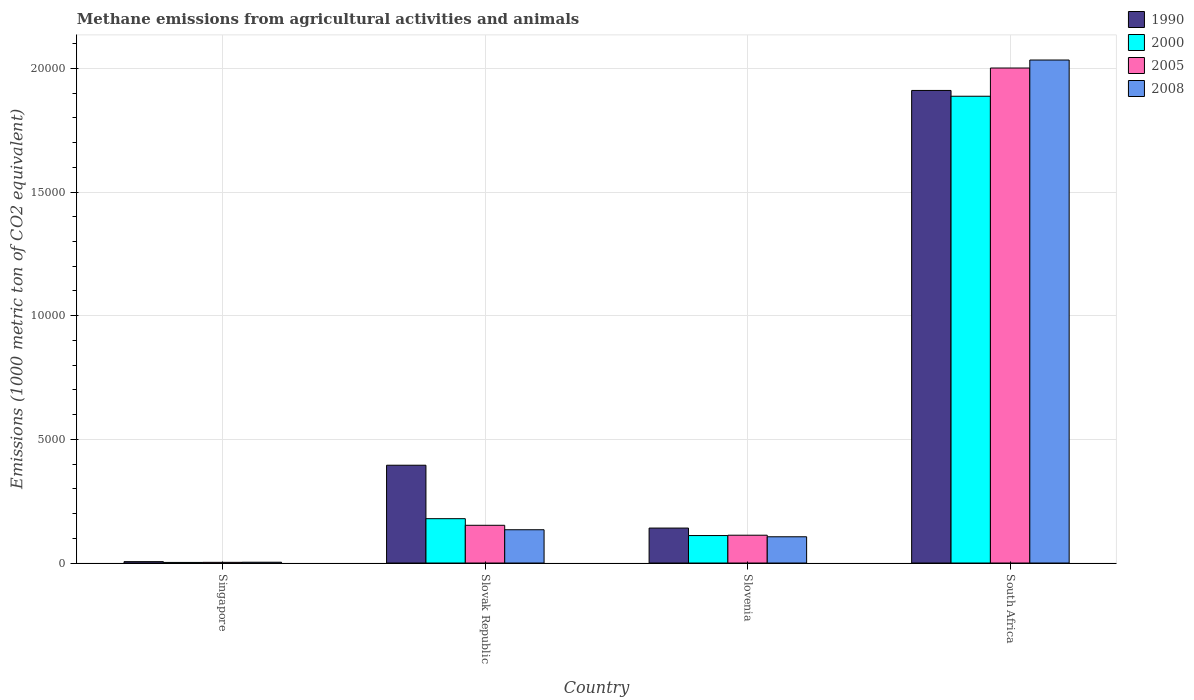Are the number of bars on each tick of the X-axis equal?
Your response must be concise. Yes. How many bars are there on the 4th tick from the left?
Give a very brief answer. 4. What is the label of the 1st group of bars from the left?
Ensure brevity in your answer.  Singapore. In how many cases, is the number of bars for a given country not equal to the number of legend labels?
Provide a succinct answer. 0. What is the amount of methane emitted in 2005 in Singapore?
Your answer should be very brief. 28.4. Across all countries, what is the maximum amount of methane emitted in 2005?
Make the answer very short. 2.00e+04. Across all countries, what is the minimum amount of methane emitted in 2005?
Make the answer very short. 28.4. In which country was the amount of methane emitted in 2000 maximum?
Your answer should be compact. South Africa. In which country was the amount of methane emitted in 2005 minimum?
Offer a terse response. Singapore. What is the total amount of methane emitted in 2000 in the graph?
Your response must be concise. 2.18e+04. What is the difference between the amount of methane emitted in 1990 in Singapore and that in Slovenia?
Offer a very short reply. -1357.9. What is the difference between the amount of methane emitted in 2000 in Slovenia and the amount of methane emitted in 1990 in Slovak Republic?
Provide a short and direct response. -2843.5. What is the average amount of methane emitted in 2008 per country?
Make the answer very short. 5694.55. In how many countries, is the amount of methane emitted in 2000 greater than 17000 1000 metric ton?
Provide a short and direct response. 1. What is the ratio of the amount of methane emitted in 1990 in Singapore to that in Slovak Republic?
Offer a terse response. 0.01. Is the difference between the amount of methane emitted in 2000 in Singapore and South Africa greater than the difference between the amount of methane emitted in 2005 in Singapore and South Africa?
Keep it short and to the point. Yes. What is the difference between the highest and the second highest amount of methane emitted in 2005?
Give a very brief answer. -401.3. What is the difference between the highest and the lowest amount of methane emitted in 1990?
Ensure brevity in your answer.  1.91e+04. What does the 4th bar from the right in South Africa represents?
Offer a terse response. 1990. Are all the bars in the graph horizontal?
Your response must be concise. No. Are the values on the major ticks of Y-axis written in scientific E-notation?
Provide a short and direct response. No. Does the graph contain any zero values?
Provide a succinct answer. No. Does the graph contain grids?
Your response must be concise. Yes. How many legend labels are there?
Offer a very short reply. 4. How are the legend labels stacked?
Offer a very short reply. Vertical. What is the title of the graph?
Provide a short and direct response. Methane emissions from agricultural activities and animals. Does "1962" appear as one of the legend labels in the graph?
Provide a short and direct response. No. What is the label or title of the Y-axis?
Keep it short and to the point. Emissions (1000 metric ton of CO2 equivalent). What is the Emissions (1000 metric ton of CO2 equivalent) in 1990 in Singapore?
Offer a very short reply. 55.6. What is the Emissions (1000 metric ton of CO2 equivalent) in 2000 in Singapore?
Ensure brevity in your answer.  24.4. What is the Emissions (1000 metric ton of CO2 equivalent) of 2005 in Singapore?
Your response must be concise. 28.4. What is the Emissions (1000 metric ton of CO2 equivalent) in 2008 in Singapore?
Provide a succinct answer. 32.8. What is the Emissions (1000 metric ton of CO2 equivalent) of 1990 in Slovak Republic?
Give a very brief answer. 3954.5. What is the Emissions (1000 metric ton of CO2 equivalent) of 2000 in Slovak Republic?
Provide a short and direct response. 1793.2. What is the Emissions (1000 metric ton of CO2 equivalent) in 2005 in Slovak Republic?
Your answer should be compact. 1525.9. What is the Emissions (1000 metric ton of CO2 equivalent) of 2008 in Slovak Republic?
Ensure brevity in your answer.  1345.7. What is the Emissions (1000 metric ton of CO2 equivalent) of 1990 in Slovenia?
Offer a very short reply. 1413.5. What is the Emissions (1000 metric ton of CO2 equivalent) in 2000 in Slovenia?
Give a very brief answer. 1111. What is the Emissions (1000 metric ton of CO2 equivalent) of 2005 in Slovenia?
Ensure brevity in your answer.  1124.6. What is the Emissions (1000 metric ton of CO2 equivalent) in 2008 in Slovenia?
Keep it short and to the point. 1061.8. What is the Emissions (1000 metric ton of CO2 equivalent) of 1990 in South Africa?
Your answer should be very brief. 1.91e+04. What is the Emissions (1000 metric ton of CO2 equivalent) in 2000 in South Africa?
Offer a terse response. 1.89e+04. What is the Emissions (1000 metric ton of CO2 equivalent) of 2005 in South Africa?
Make the answer very short. 2.00e+04. What is the Emissions (1000 metric ton of CO2 equivalent) in 2008 in South Africa?
Ensure brevity in your answer.  2.03e+04. Across all countries, what is the maximum Emissions (1000 metric ton of CO2 equivalent) in 1990?
Make the answer very short. 1.91e+04. Across all countries, what is the maximum Emissions (1000 metric ton of CO2 equivalent) in 2000?
Your answer should be very brief. 1.89e+04. Across all countries, what is the maximum Emissions (1000 metric ton of CO2 equivalent) of 2005?
Give a very brief answer. 2.00e+04. Across all countries, what is the maximum Emissions (1000 metric ton of CO2 equivalent) in 2008?
Offer a very short reply. 2.03e+04. Across all countries, what is the minimum Emissions (1000 metric ton of CO2 equivalent) of 1990?
Give a very brief answer. 55.6. Across all countries, what is the minimum Emissions (1000 metric ton of CO2 equivalent) in 2000?
Ensure brevity in your answer.  24.4. Across all countries, what is the minimum Emissions (1000 metric ton of CO2 equivalent) in 2005?
Ensure brevity in your answer.  28.4. Across all countries, what is the minimum Emissions (1000 metric ton of CO2 equivalent) in 2008?
Your response must be concise. 32.8. What is the total Emissions (1000 metric ton of CO2 equivalent) of 1990 in the graph?
Make the answer very short. 2.45e+04. What is the total Emissions (1000 metric ton of CO2 equivalent) of 2000 in the graph?
Keep it short and to the point. 2.18e+04. What is the total Emissions (1000 metric ton of CO2 equivalent) of 2005 in the graph?
Give a very brief answer. 2.27e+04. What is the total Emissions (1000 metric ton of CO2 equivalent) of 2008 in the graph?
Ensure brevity in your answer.  2.28e+04. What is the difference between the Emissions (1000 metric ton of CO2 equivalent) in 1990 in Singapore and that in Slovak Republic?
Provide a succinct answer. -3898.9. What is the difference between the Emissions (1000 metric ton of CO2 equivalent) in 2000 in Singapore and that in Slovak Republic?
Ensure brevity in your answer.  -1768.8. What is the difference between the Emissions (1000 metric ton of CO2 equivalent) of 2005 in Singapore and that in Slovak Republic?
Provide a short and direct response. -1497.5. What is the difference between the Emissions (1000 metric ton of CO2 equivalent) in 2008 in Singapore and that in Slovak Republic?
Your answer should be very brief. -1312.9. What is the difference between the Emissions (1000 metric ton of CO2 equivalent) of 1990 in Singapore and that in Slovenia?
Offer a terse response. -1357.9. What is the difference between the Emissions (1000 metric ton of CO2 equivalent) of 2000 in Singapore and that in Slovenia?
Keep it short and to the point. -1086.6. What is the difference between the Emissions (1000 metric ton of CO2 equivalent) of 2005 in Singapore and that in Slovenia?
Give a very brief answer. -1096.2. What is the difference between the Emissions (1000 metric ton of CO2 equivalent) of 2008 in Singapore and that in Slovenia?
Give a very brief answer. -1029. What is the difference between the Emissions (1000 metric ton of CO2 equivalent) of 1990 in Singapore and that in South Africa?
Your response must be concise. -1.91e+04. What is the difference between the Emissions (1000 metric ton of CO2 equivalent) of 2000 in Singapore and that in South Africa?
Provide a succinct answer. -1.88e+04. What is the difference between the Emissions (1000 metric ton of CO2 equivalent) in 2005 in Singapore and that in South Africa?
Offer a very short reply. -2.00e+04. What is the difference between the Emissions (1000 metric ton of CO2 equivalent) in 2008 in Singapore and that in South Africa?
Keep it short and to the point. -2.03e+04. What is the difference between the Emissions (1000 metric ton of CO2 equivalent) in 1990 in Slovak Republic and that in Slovenia?
Keep it short and to the point. 2541. What is the difference between the Emissions (1000 metric ton of CO2 equivalent) of 2000 in Slovak Republic and that in Slovenia?
Offer a very short reply. 682.2. What is the difference between the Emissions (1000 metric ton of CO2 equivalent) in 2005 in Slovak Republic and that in Slovenia?
Ensure brevity in your answer.  401.3. What is the difference between the Emissions (1000 metric ton of CO2 equivalent) of 2008 in Slovak Republic and that in Slovenia?
Your response must be concise. 283.9. What is the difference between the Emissions (1000 metric ton of CO2 equivalent) of 1990 in Slovak Republic and that in South Africa?
Give a very brief answer. -1.52e+04. What is the difference between the Emissions (1000 metric ton of CO2 equivalent) in 2000 in Slovak Republic and that in South Africa?
Your answer should be compact. -1.71e+04. What is the difference between the Emissions (1000 metric ton of CO2 equivalent) in 2005 in Slovak Republic and that in South Africa?
Your answer should be very brief. -1.85e+04. What is the difference between the Emissions (1000 metric ton of CO2 equivalent) in 2008 in Slovak Republic and that in South Africa?
Give a very brief answer. -1.90e+04. What is the difference between the Emissions (1000 metric ton of CO2 equivalent) of 1990 in Slovenia and that in South Africa?
Your answer should be compact. -1.77e+04. What is the difference between the Emissions (1000 metric ton of CO2 equivalent) in 2000 in Slovenia and that in South Africa?
Provide a short and direct response. -1.78e+04. What is the difference between the Emissions (1000 metric ton of CO2 equivalent) in 2005 in Slovenia and that in South Africa?
Ensure brevity in your answer.  -1.89e+04. What is the difference between the Emissions (1000 metric ton of CO2 equivalent) of 2008 in Slovenia and that in South Africa?
Your answer should be very brief. -1.93e+04. What is the difference between the Emissions (1000 metric ton of CO2 equivalent) in 1990 in Singapore and the Emissions (1000 metric ton of CO2 equivalent) in 2000 in Slovak Republic?
Your response must be concise. -1737.6. What is the difference between the Emissions (1000 metric ton of CO2 equivalent) in 1990 in Singapore and the Emissions (1000 metric ton of CO2 equivalent) in 2005 in Slovak Republic?
Provide a succinct answer. -1470.3. What is the difference between the Emissions (1000 metric ton of CO2 equivalent) in 1990 in Singapore and the Emissions (1000 metric ton of CO2 equivalent) in 2008 in Slovak Republic?
Provide a short and direct response. -1290.1. What is the difference between the Emissions (1000 metric ton of CO2 equivalent) in 2000 in Singapore and the Emissions (1000 metric ton of CO2 equivalent) in 2005 in Slovak Republic?
Your answer should be compact. -1501.5. What is the difference between the Emissions (1000 metric ton of CO2 equivalent) of 2000 in Singapore and the Emissions (1000 metric ton of CO2 equivalent) of 2008 in Slovak Republic?
Offer a terse response. -1321.3. What is the difference between the Emissions (1000 metric ton of CO2 equivalent) in 2005 in Singapore and the Emissions (1000 metric ton of CO2 equivalent) in 2008 in Slovak Republic?
Make the answer very short. -1317.3. What is the difference between the Emissions (1000 metric ton of CO2 equivalent) of 1990 in Singapore and the Emissions (1000 metric ton of CO2 equivalent) of 2000 in Slovenia?
Offer a very short reply. -1055.4. What is the difference between the Emissions (1000 metric ton of CO2 equivalent) of 1990 in Singapore and the Emissions (1000 metric ton of CO2 equivalent) of 2005 in Slovenia?
Your response must be concise. -1069. What is the difference between the Emissions (1000 metric ton of CO2 equivalent) in 1990 in Singapore and the Emissions (1000 metric ton of CO2 equivalent) in 2008 in Slovenia?
Give a very brief answer. -1006.2. What is the difference between the Emissions (1000 metric ton of CO2 equivalent) of 2000 in Singapore and the Emissions (1000 metric ton of CO2 equivalent) of 2005 in Slovenia?
Offer a very short reply. -1100.2. What is the difference between the Emissions (1000 metric ton of CO2 equivalent) of 2000 in Singapore and the Emissions (1000 metric ton of CO2 equivalent) of 2008 in Slovenia?
Provide a short and direct response. -1037.4. What is the difference between the Emissions (1000 metric ton of CO2 equivalent) of 2005 in Singapore and the Emissions (1000 metric ton of CO2 equivalent) of 2008 in Slovenia?
Offer a terse response. -1033.4. What is the difference between the Emissions (1000 metric ton of CO2 equivalent) of 1990 in Singapore and the Emissions (1000 metric ton of CO2 equivalent) of 2000 in South Africa?
Give a very brief answer. -1.88e+04. What is the difference between the Emissions (1000 metric ton of CO2 equivalent) in 1990 in Singapore and the Emissions (1000 metric ton of CO2 equivalent) in 2005 in South Africa?
Provide a succinct answer. -2.00e+04. What is the difference between the Emissions (1000 metric ton of CO2 equivalent) of 1990 in Singapore and the Emissions (1000 metric ton of CO2 equivalent) of 2008 in South Africa?
Offer a terse response. -2.03e+04. What is the difference between the Emissions (1000 metric ton of CO2 equivalent) of 2000 in Singapore and the Emissions (1000 metric ton of CO2 equivalent) of 2005 in South Africa?
Offer a very short reply. -2.00e+04. What is the difference between the Emissions (1000 metric ton of CO2 equivalent) in 2000 in Singapore and the Emissions (1000 metric ton of CO2 equivalent) in 2008 in South Africa?
Your answer should be compact. -2.03e+04. What is the difference between the Emissions (1000 metric ton of CO2 equivalent) of 2005 in Singapore and the Emissions (1000 metric ton of CO2 equivalent) of 2008 in South Africa?
Offer a very short reply. -2.03e+04. What is the difference between the Emissions (1000 metric ton of CO2 equivalent) of 1990 in Slovak Republic and the Emissions (1000 metric ton of CO2 equivalent) of 2000 in Slovenia?
Your answer should be compact. 2843.5. What is the difference between the Emissions (1000 metric ton of CO2 equivalent) of 1990 in Slovak Republic and the Emissions (1000 metric ton of CO2 equivalent) of 2005 in Slovenia?
Provide a short and direct response. 2829.9. What is the difference between the Emissions (1000 metric ton of CO2 equivalent) of 1990 in Slovak Republic and the Emissions (1000 metric ton of CO2 equivalent) of 2008 in Slovenia?
Make the answer very short. 2892.7. What is the difference between the Emissions (1000 metric ton of CO2 equivalent) in 2000 in Slovak Republic and the Emissions (1000 metric ton of CO2 equivalent) in 2005 in Slovenia?
Ensure brevity in your answer.  668.6. What is the difference between the Emissions (1000 metric ton of CO2 equivalent) of 2000 in Slovak Republic and the Emissions (1000 metric ton of CO2 equivalent) of 2008 in Slovenia?
Ensure brevity in your answer.  731.4. What is the difference between the Emissions (1000 metric ton of CO2 equivalent) in 2005 in Slovak Republic and the Emissions (1000 metric ton of CO2 equivalent) in 2008 in Slovenia?
Give a very brief answer. 464.1. What is the difference between the Emissions (1000 metric ton of CO2 equivalent) in 1990 in Slovak Republic and the Emissions (1000 metric ton of CO2 equivalent) in 2000 in South Africa?
Your response must be concise. -1.49e+04. What is the difference between the Emissions (1000 metric ton of CO2 equivalent) in 1990 in Slovak Republic and the Emissions (1000 metric ton of CO2 equivalent) in 2005 in South Africa?
Provide a succinct answer. -1.61e+04. What is the difference between the Emissions (1000 metric ton of CO2 equivalent) of 1990 in Slovak Republic and the Emissions (1000 metric ton of CO2 equivalent) of 2008 in South Africa?
Keep it short and to the point. -1.64e+04. What is the difference between the Emissions (1000 metric ton of CO2 equivalent) in 2000 in Slovak Republic and the Emissions (1000 metric ton of CO2 equivalent) in 2005 in South Africa?
Provide a succinct answer. -1.82e+04. What is the difference between the Emissions (1000 metric ton of CO2 equivalent) of 2000 in Slovak Republic and the Emissions (1000 metric ton of CO2 equivalent) of 2008 in South Africa?
Offer a very short reply. -1.85e+04. What is the difference between the Emissions (1000 metric ton of CO2 equivalent) of 2005 in Slovak Republic and the Emissions (1000 metric ton of CO2 equivalent) of 2008 in South Africa?
Your answer should be very brief. -1.88e+04. What is the difference between the Emissions (1000 metric ton of CO2 equivalent) of 1990 in Slovenia and the Emissions (1000 metric ton of CO2 equivalent) of 2000 in South Africa?
Offer a very short reply. -1.75e+04. What is the difference between the Emissions (1000 metric ton of CO2 equivalent) in 1990 in Slovenia and the Emissions (1000 metric ton of CO2 equivalent) in 2005 in South Africa?
Make the answer very short. -1.86e+04. What is the difference between the Emissions (1000 metric ton of CO2 equivalent) of 1990 in Slovenia and the Emissions (1000 metric ton of CO2 equivalent) of 2008 in South Africa?
Offer a very short reply. -1.89e+04. What is the difference between the Emissions (1000 metric ton of CO2 equivalent) in 2000 in Slovenia and the Emissions (1000 metric ton of CO2 equivalent) in 2005 in South Africa?
Your answer should be very brief. -1.89e+04. What is the difference between the Emissions (1000 metric ton of CO2 equivalent) of 2000 in Slovenia and the Emissions (1000 metric ton of CO2 equivalent) of 2008 in South Africa?
Ensure brevity in your answer.  -1.92e+04. What is the difference between the Emissions (1000 metric ton of CO2 equivalent) in 2005 in Slovenia and the Emissions (1000 metric ton of CO2 equivalent) in 2008 in South Africa?
Your response must be concise. -1.92e+04. What is the average Emissions (1000 metric ton of CO2 equivalent) in 1990 per country?
Offer a very short reply. 6132.95. What is the average Emissions (1000 metric ton of CO2 equivalent) in 2000 per country?
Keep it short and to the point. 5450.55. What is the average Emissions (1000 metric ton of CO2 equivalent) in 2005 per country?
Provide a short and direct response. 5673.35. What is the average Emissions (1000 metric ton of CO2 equivalent) in 2008 per country?
Make the answer very short. 5694.55. What is the difference between the Emissions (1000 metric ton of CO2 equivalent) of 1990 and Emissions (1000 metric ton of CO2 equivalent) of 2000 in Singapore?
Provide a short and direct response. 31.2. What is the difference between the Emissions (1000 metric ton of CO2 equivalent) in 1990 and Emissions (1000 metric ton of CO2 equivalent) in 2005 in Singapore?
Your response must be concise. 27.2. What is the difference between the Emissions (1000 metric ton of CO2 equivalent) in 1990 and Emissions (1000 metric ton of CO2 equivalent) in 2008 in Singapore?
Make the answer very short. 22.8. What is the difference between the Emissions (1000 metric ton of CO2 equivalent) in 1990 and Emissions (1000 metric ton of CO2 equivalent) in 2000 in Slovak Republic?
Give a very brief answer. 2161.3. What is the difference between the Emissions (1000 metric ton of CO2 equivalent) in 1990 and Emissions (1000 metric ton of CO2 equivalent) in 2005 in Slovak Republic?
Provide a succinct answer. 2428.6. What is the difference between the Emissions (1000 metric ton of CO2 equivalent) in 1990 and Emissions (1000 metric ton of CO2 equivalent) in 2008 in Slovak Republic?
Provide a short and direct response. 2608.8. What is the difference between the Emissions (1000 metric ton of CO2 equivalent) of 2000 and Emissions (1000 metric ton of CO2 equivalent) of 2005 in Slovak Republic?
Offer a very short reply. 267.3. What is the difference between the Emissions (1000 metric ton of CO2 equivalent) of 2000 and Emissions (1000 metric ton of CO2 equivalent) of 2008 in Slovak Republic?
Ensure brevity in your answer.  447.5. What is the difference between the Emissions (1000 metric ton of CO2 equivalent) of 2005 and Emissions (1000 metric ton of CO2 equivalent) of 2008 in Slovak Republic?
Provide a succinct answer. 180.2. What is the difference between the Emissions (1000 metric ton of CO2 equivalent) of 1990 and Emissions (1000 metric ton of CO2 equivalent) of 2000 in Slovenia?
Provide a short and direct response. 302.5. What is the difference between the Emissions (1000 metric ton of CO2 equivalent) in 1990 and Emissions (1000 metric ton of CO2 equivalent) in 2005 in Slovenia?
Your answer should be very brief. 288.9. What is the difference between the Emissions (1000 metric ton of CO2 equivalent) of 1990 and Emissions (1000 metric ton of CO2 equivalent) of 2008 in Slovenia?
Keep it short and to the point. 351.7. What is the difference between the Emissions (1000 metric ton of CO2 equivalent) of 2000 and Emissions (1000 metric ton of CO2 equivalent) of 2008 in Slovenia?
Offer a terse response. 49.2. What is the difference between the Emissions (1000 metric ton of CO2 equivalent) of 2005 and Emissions (1000 metric ton of CO2 equivalent) of 2008 in Slovenia?
Your response must be concise. 62.8. What is the difference between the Emissions (1000 metric ton of CO2 equivalent) in 1990 and Emissions (1000 metric ton of CO2 equivalent) in 2000 in South Africa?
Offer a terse response. 234.6. What is the difference between the Emissions (1000 metric ton of CO2 equivalent) in 1990 and Emissions (1000 metric ton of CO2 equivalent) in 2005 in South Africa?
Provide a succinct answer. -906.3. What is the difference between the Emissions (1000 metric ton of CO2 equivalent) in 1990 and Emissions (1000 metric ton of CO2 equivalent) in 2008 in South Africa?
Your answer should be compact. -1229.7. What is the difference between the Emissions (1000 metric ton of CO2 equivalent) of 2000 and Emissions (1000 metric ton of CO2 equivalent) of 2005 in South Africa?
Your response must be concise. -1140.9. What is the difference between the Emissions (1000 metric ton of CO2 equivalent) in 2000 and Emissions (1000 metric ton of CO2 equivalent) in 2008 in South Africa?
Give a very brief answer. -1464.3. What is the difference between the Emissions (1000 metric ton of CO2 equivalent) in 2005 and Emissions (1000 metric ton of CO2 equivalent) in 2008 in South Africa?
Keep it short and to the point. -323.4. What is the ratio of the Emissions (1000 metric ton of CO2 equivalent) of 1990 in Singapore to that in Slovak Republic?
Provide a succinct answer. 0.01. What is the ratio of the Emissions (1000 metric ton of CO2 equivalent) in 2000 in Singapore to that in Slovak Republic?
Your answer should be very brief. 0.01. What is the ratio of the Emissions (1000 metric ton of CO2 equivalent) in 2005 in Singapore to that in Slovak Republic?
Provide a short and direct response. 0.02. What is the ratio of the Emissions (1000 metric ton of CO2 equivalent) of 2008 in Singapore to that in Slovak Republic?
Provide a succinct answer. 0.02. What is the ratio of the Emissions (1000 metric ton of CO2 equivalent) in 1990 in Singapore to that in Slovenia?
Your response must be concise. 0.04. What is the ratio of the Emissions (1000 metric ton of CO2 equivalent) in 2000 in Singapore to that in Slovenia?
Your answer should be very brief. 0.02. What is the ratio of the Emissions (1000 metric ton of CO2 equivalent) in 2005 in Singapore to that in Slovenia?
Give a very brief answer. 0.03. What is the ratio of the Emissions (1000 metric ton of CO2 equivalent) of 2008 in Singapore to that in Slovenia?
Ensure brevity in your answer.  0.03. What is the ratio of the Emissions (1000 metric ton of CO2 equivalent) of 1990 in Singapore to that in South Africa?
Ensure brevity in your answer.  0. What is the ratio of the Emissions (1000 metric ton of CO2 equivalent) of 2000 in Singapore to that in South Africa?
Your response must be concise. 0. What is the ratio of the Emissions (1000 metric ton of CO2 equivalent) of 2005 in Singapore to that in South Africa?
Give a very brief answer. 0. What is the ratio of the Emissions (1000 metric ton of CO2 equivalent) of 2008 in Singapore to that in South Africa?
Your answer should be compact. 0. What is the ratio of the Emissions (1000 metric ton of CO2 equivalent) in 1990 in Slovak Republic to that in Slovenia?
Your answer should be very brief. 2.8. What is the ratio of the Emissions (1000 metric ton of CO2 equivalent) in 2000 in Slovak Republic to that in Slovenia?
Keep it short and to the point. 1.61. What is the ratio of the Emissions (1000 metric ton of CO2 equivalent) in 2005 in Slovak Republic to that in Slovenia?
Offer a terse response. 1.36. What is the ratio of the Emissions (1000 metric ton of CO2 equivalent) of 2008 in Slovak Republic to that in Slovenia?
Provide a succinct answer. 1.27. What is the ratio of the Emissions (1000 metric ton of CO2 equivalent) of 1990 in Slovak Republic to that in South Africa?
Make the answer very short. 0.21. What is the ratio of the Emissions (1000 metric ton of CO2 equivalent) of 2000 in Slovak Republic to that in South Africa?
Your answer should be very brief. 0.1. What is the ratio of the Emissions (1000 metric ton of CO2 equivalent) of 2005 in Slovak Republic to that in South Africa?
Your answer should be compact. 0.08. What is the ratio of the Emissions (1000 metric ton of CO2 equivalent) in 2008 in Slovak Republic to that in South Africa?
Give a very brief answer. 0.07. What is the ratio of the Emissions (1000 metric ton of CO2 equivalent) of 1990 in Slovenia to that in South Africa?
Your response must be concise. 0.07. What is the ratio of the Emissions (1000 metric ton of CO2 equivalent) of 2000 in Slovenia to that in South Africa?
Your response must be concise. 0.06. What is the ratio of the Emissions (1000 metric ton of CO2 equivalent) of 2005 in Slovenia to that in South Africa?
Make the answer very short. 0.06. What is the ratio of the Emissions (1000 metric ton of CO2 equivalent) in 2008 in Slovenia to that in South Africa?
Ensure brevity in your answer.  0.05. What is the difference between the highest and the second highest Emissions (1000 metric ton of CO2 equivalent) of 1990?
Ensure brevity in your answer.  1.52e+04. What is the difference between the highest and the second highest Emissions (1000 metric ton of CO2 equivalent) in 2000?
Make the answer very short. 1.71e+04. What is the difference between the highest and the second highest Emissions (1000 metric ton of CO2 equivalent) in 2005?
Offer a terse response. 1.85e+04. What is the difference between the highest and the second highest Emissions (1000 metric ton of CO2 equivalent) of 2008?
Make the answer very short. 1.90e+04. What is the difference between the highest and the lowest Emissions (1000 metric ton of CO2 equivalent) of 1990?
Give a very brief answer. 1.91e+04. What is the difference between the highest and the lowest Emissions (1000 metric ton of CO2 equivalent) in 2000?
Provide a succinct answer. 1.88e+04. What is the difference between the highest and the lowest Emissions (1000 metric ton of CO2 equivalent) in 2005?
Keep it short and to the point. 2.00e+04. What is the difference between the highest and the lowest Emissions (1000 metric ton of CO2 equivalent) in 2008?
Keep it short and to the point. 2.03e+04. 